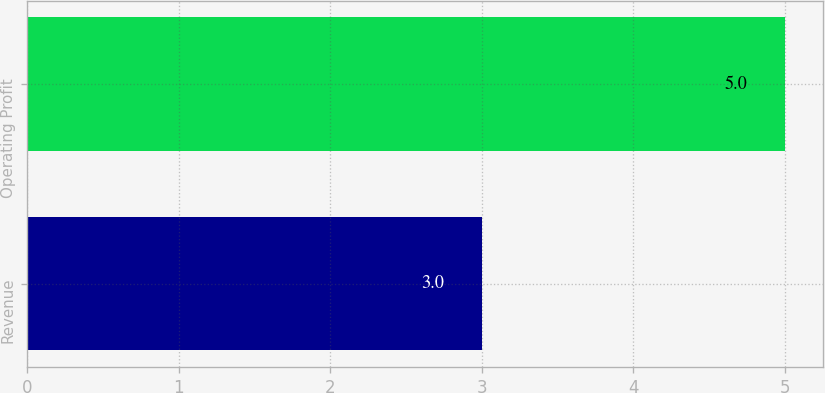<chart> <loc_0><loc_0><loc_500><loc_500><bar_chart><fcel>Revenue<fcel>Operating Profit<nl><fcel>3<fcel>5<nl></chart> 